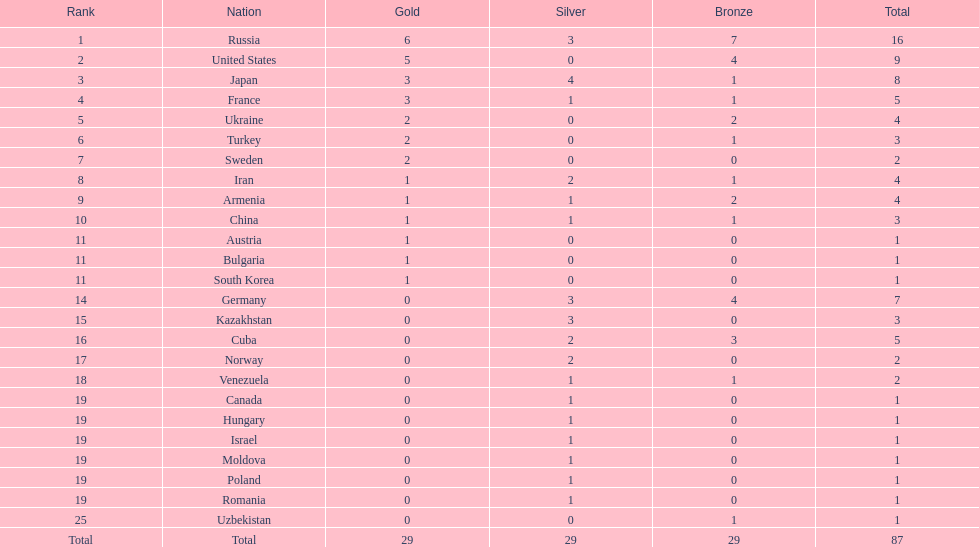How many silver medals did turkey win? 0. 